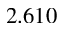<formula> <loc_0><loc_0><loc_500><loc_500>2 . 6 1 0</formula> 